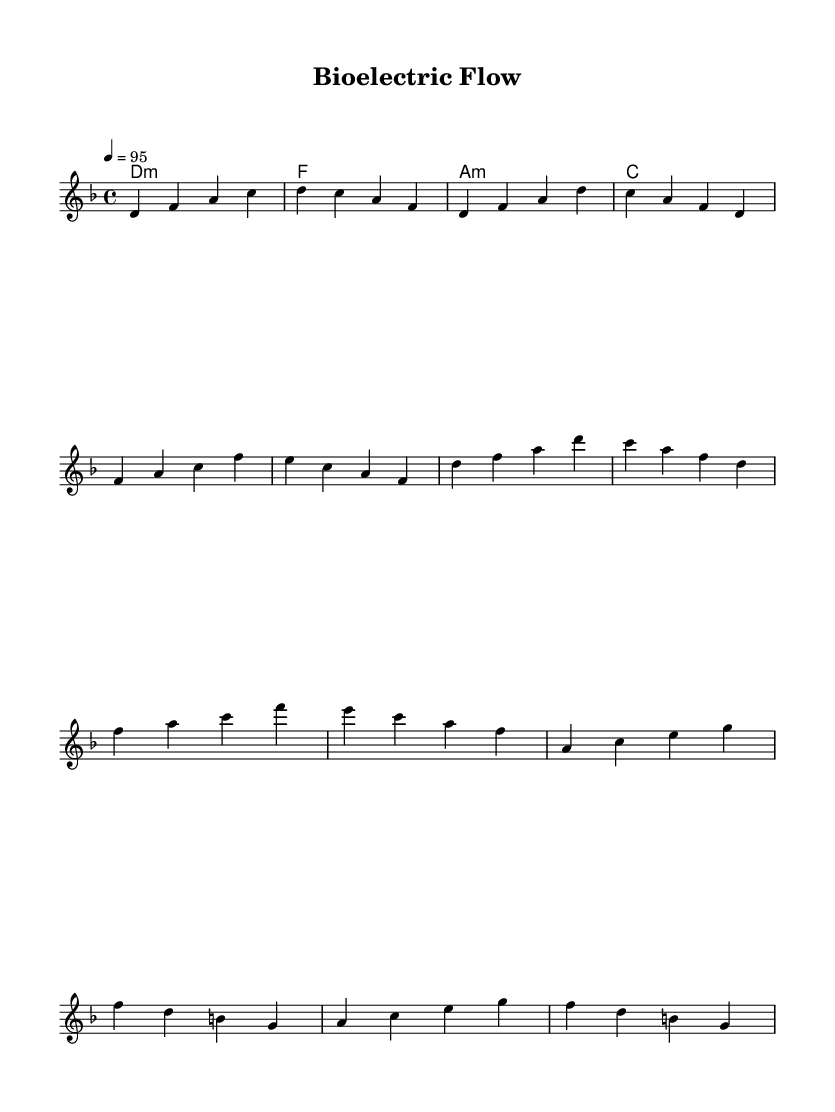What is the key signature of this music? The key signature indicated at the beginning of the score is D minor, which typically has one flat (B flat). This can be identified by looking at the key signature section of the sheet music.
Answer: D minor What is the time signature of this music? The time signature is found at the beginning of the score, represented as 4/4, which indicates there are four beats per measure and the quarter note gets one beat.
Answer: 4/4 What is the tempo marking in this music? The tempo is marked with a quarter note equals 95, indicating the speed at which the piece should be performed. To find this, one looks for the tempo marking, which specifies how many beats per minute the music should be played.
Answer: 95 How many sections are present in the music? The score has several distinct sections: Intro, Verse, Chorus, and Bridge. Counting these sections gives a total of four.
Answer: 4 What is the first note of the melody? The first note of the melody is D, which can be seen at the start of the melody line in the sheet music.
Answer: D What chord follows the A minor chord in the harmony? The A minor chord is followed by the C major chord, which can be determined by looking at the chord progression listed in the harmonies section of the sheet music.
Answer: C Which part of the music has an ascending movement? The Bridge section features an ascending movement starting from A to G, identifiable by examining the specific notes played in that section.
Answer: Bridge 